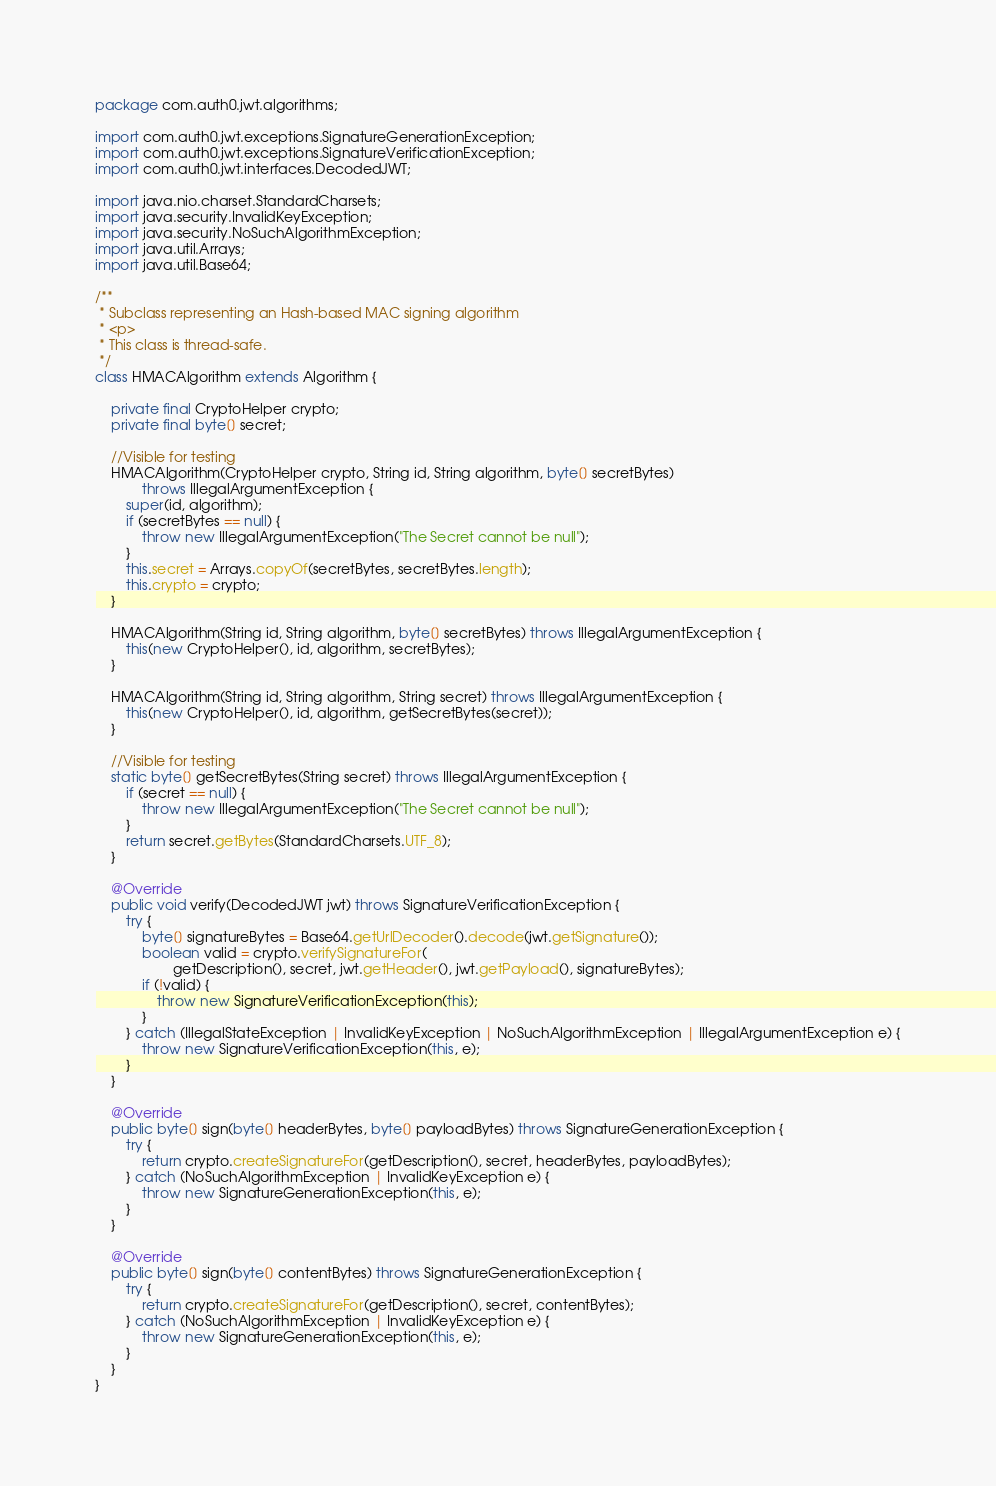<code> <loc_0><loc_0><loc_500><loc_500><_Java_>package com.auth0.jwt.algorithms;

import com.auth0.jwt.exceptions.SignatureGenerationException;
import com.auth0.jwt.exceptions.SignatureVerificationException;
import com.auth0.jwt.interfaces.DecodedJWT;

import java.nio.charset.StandardCharsets;
import java.security.InvalidKeyException;
import java.security.NoSuchAlgorithmException;
import java.util.Arrays;
import java.util.Base64;

/**
 * Subclass representing an Hash-based MAC signing algorithm
 * <p>
 * This class is thread-safe.
 */
class HMACAlgorithm extends Algorithm {

    private final CryptoHelper crypto;
    private final byte[] secret;

    //Visible for testing
    HMACAlgorithm(CryptoHelper crypto, String id, String algorithm, byte[] secretBytes)
            throws IllegalArgumentException {
        super(id, algorithm);
        if (secretBytes == null) {
            throw new IllegalArgumentException("The Secret cannot be null");
        }
        this.secret = Arrays.copyOf(secretBytes, secretBytes.length);
        this.crypto = crypto;
    }

    HMACAlgorithm(String id, String algorithm, byte[] secretBytes) throws IllegalArgumentException {
        this(new CryptoHelper(), id, algorithm, secretBytes);
    }

    HMACAlgorithm(String id, String algorithm, String secret) throws IllegalArgumentException {
        this(new CryptoHelper(), id, algorithm, getSecretBytes(secret));
    }

    //Visible for testing
    static byte[] getSecretBytes(String secret) throws IllegalArgumentException {
        if (secret == null) {
            throw new IllegalArgumentException("The Secret cannot be null");
        }
        return secret.getBytes(StandardCharsets.UTF_8);
    }

    @Override
    public void verify(DecodedJWT jwt) throws SignatureVerificationException {
        try {
            byte[] signatureBytes = Base64.getUrlDecoder().decode(jwt.getSignature());
            boolean valid = crypto.verifySignatureFor(
                    getDescription(), secret, jwt.getHeader(), jwt.getPayload(), signatureBytes);
            if (!valid) {
                throw new SignatureVerificationException(this);
            }
        } catch (IllegalStateException | InvalidKeyException | NoSuchAlgorithmException | IllegalArgumentException e) {
            throw new SignatureVerificationException(this, e);
        }
    }

    @Override
    public byte[] sign(byte[] headerBytes, byte[] payloadBytes) throws SignatureGenerationException {
        try {
            return crypto.createSignatureFor(getDescription(), secret, headerBytes, payloadBytes);
        } catch (NoSuchAlgorithmException | InvalidKeyException e) {
            throw new SignatureGenerationException(this, e);
        }
    }

    @Override
    public byte[] sign(byte[] contentBytes) throws SignatureGenerationException {
        try {
            return crypto.createSignatureFor(getDescription(), secret, contentBytes);
        } catch (NoSuchAlgorithmException | InvalidKeyException e) {
            throw new SignatureGenerationException(this, e);
        }
    }
}
</code> 